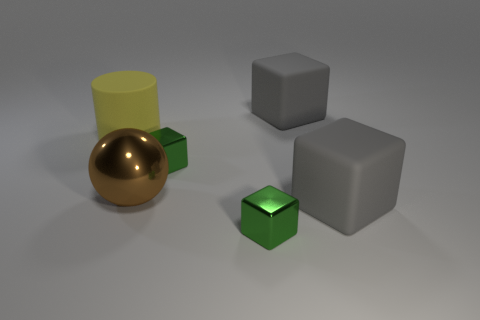Subtract all cubes. How many objects are left? 2 Subtract all cyan spheres. Subtract all green blocks. How many spheres are left? 1 Subtract all brown cubes. How many green cylinders are left? 0 Subtract all green cubes. Subtract all small things. How many objects are left? 2 Add 2 tiny shiny objects. How many tiny shiny objects are left? 4 Add 3 brown metal balls. How many brown metal balls exist? 4 Add 4 small green metallic blocks. How many objects exist? 10 Subtract all green blocks. How many blocks are left? 2 Subtract 0 red spheres. How many objects are left? 6 Subtract 1 spheres. How many spheres are left? 0 